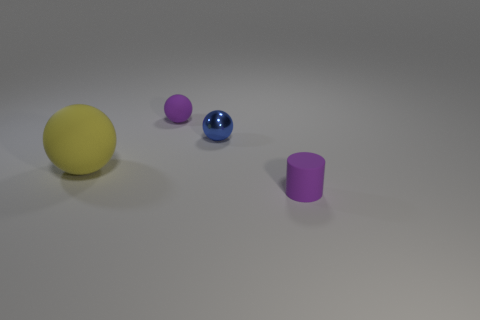What size is the purple matte object that is left of the small rubber thing that is on the right side of the purple object behind the small purple cylinder?
Your answer should be compact. Small. Is there a big green cube made of the same material as the tiny purple cylinder?
Give a very brief answer. No. What is the shape of the yellow object?
Provide a succinct answer. Sphere. What is the color of the sphere that is the same material as the large yellow object?
Your response must be concise. Purple. What number of red objects are big things or small rubber cylinders?
Your answer should be very brief. 0. Are there more small purple matte objects than things?
Provide a short and direct response. No. What number of objects are either small purple things in front of the blue thing or objects that are to the right of the large yellow rubber sphere?
Make the answer very short. 3. The matte ball that is the same size as the metal thing is what color?
Offer a terse response. Purple. Are the tiny purple cylinder and the small blue thing made of the same material?
Your response must be concise. No. What material is the ball that is right of the small ball that is behind the blue object?
Your response must be concise. Metal. 